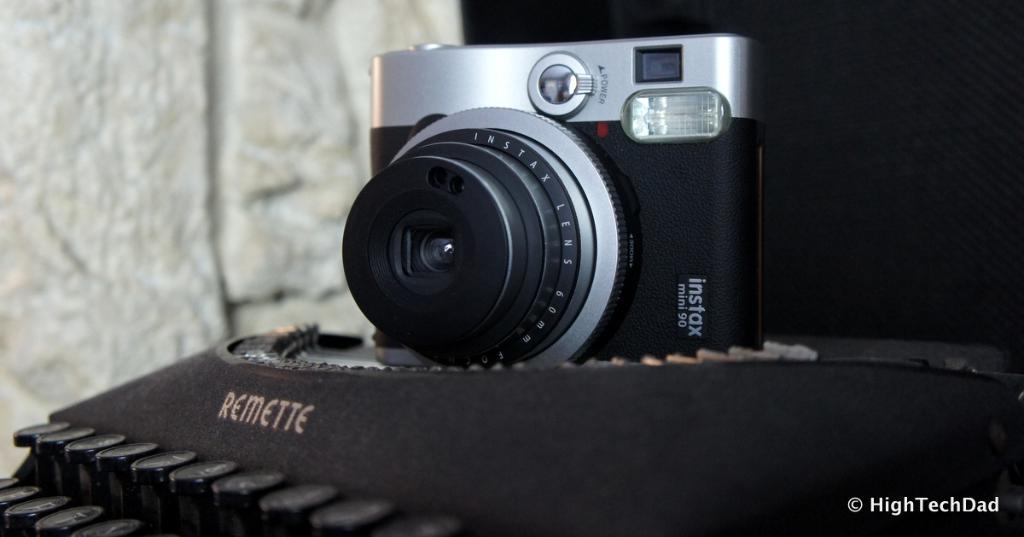What is the main object in the image? There is a digital camera in the image. What colors can be seen on the digital camera? The digital camera is black and silver in color. What can be seen behind the digital camera? There is a wall in the background of the image. What type of value system does the digital camera represent in the image? The image does not convey any information about a value system, as it only features a digital camera and a wall in the background. 